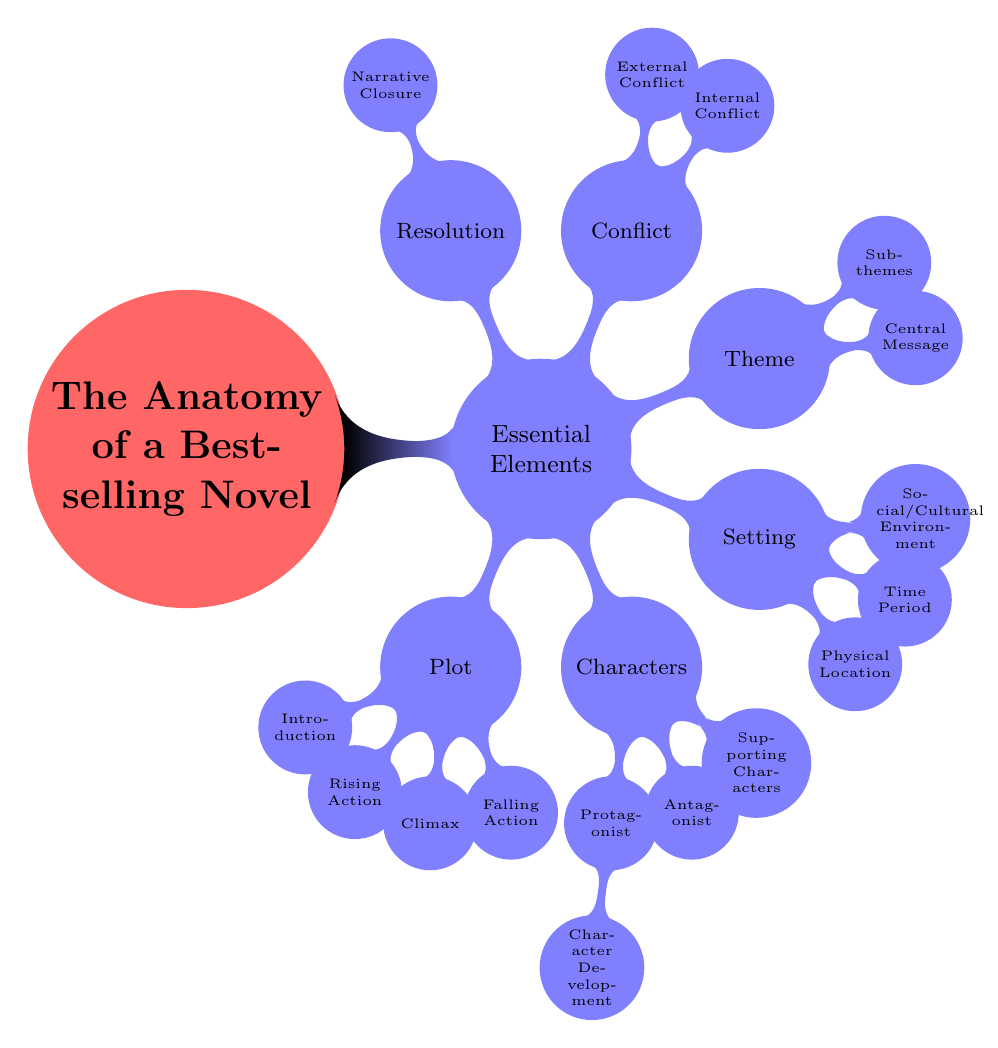What is the central concept of the diagram? The diagram's central concept is indicated at the top, labeled as "The Anatomy of a Bestselling Novel," which serves as the main topic of discussion.
Answer: The Anatomy of a Bestselling Novel How many essential elements are identified in the diagram? By counting the main child nodes connected to "Essential Elements," we identify six distinct elements: Plot, Characters, Setting, Theme, Conflict, and Resolution.
Answer: Six What is the first step in the plot structure? The first step in the plot structure is represented by a node connected directly to "Plot" labeled "Introduction," indicating the beginning of the story's narrative arc.
Answer: Introduction Which character type is associated with character development? The node labeled "Character Development" branches from the node labeled "Protagonist," indicating that character development is specifically related to the protagonist of the story.
Answer: Protagonist What are the two types of conflict mentioned in the diagram? The node labeled "Conflict" includes two child nodes named "Internal Conflict" and "External Conflict," which denote the two primary forms of conflict represented in the narrative structure.
Answer: Internal Conflict, External Conflict What relationship exists between “Theme” and its components? "Theme" is depicted as a central concept that branches into two elements: "Central Message" and "Sub-themes," indicating that themes often encompass a main message and additional related themes that support it.
Answer: Central Message, Sub-themes What element is focused on providing narrative closure? The element focused on providing narrative closure is represented by the node labeled "Resolution," which signifies the concluding part of the story where final outcomes are revealed.
Answer: Resolution How is the antagonist described in the diagram? The node labeled "Antagonist" is a child node under "Characters," indicating that the antagonist is a critical character type that opposes the protagonist, but no additional details about the antagonist are provided in the diagram.
Answer: Antagonist What three aspects are included in the setting? The "Setting" node branches into three aspects: "Physical Location," "Time Period," and "Social/Cultural Environment," highlighting the various dimensions that set the stage for the storyline.
Answer: Physical Location, Time Period, Social/Cultural Environment 